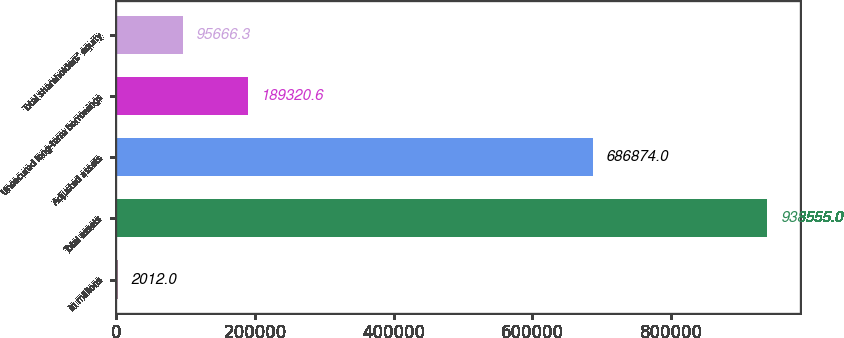Convert chart. <chart><loc_0><loc_0><loc_500><loc_500><bar_chart><fcel>in millions<fcel>Total assets<fcel>Adjusted assets<fcel>Unsecured long-term borrowings<fcel>Total shareholders' equity<nl><fcel>2012<fcel>938555<fcel>686874<fcel>189321<fcel>95666.3<nl></chart> 